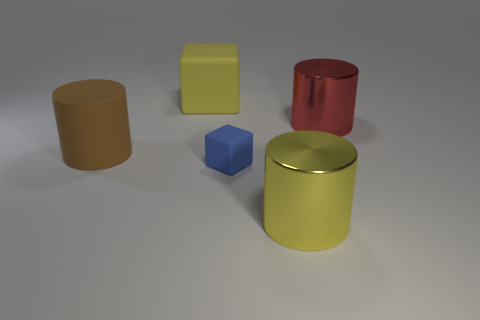Can you guess the texture of the objects? The objects appear to have smooth surfaces with no discernible texture, which is often indicative of materials such as plastic or metal. There are no visible grains, bumps, or irregularities that would suggest a textured material.  Considering their shapes, how do these objects look like they could be used? The shapes of the objects suggest they could be generic containers or purely decorative. The cylinders could function as storage canisters or vases, while the cube may serve as a paperweight or another form of geometric decoration. Their usage would be particular to the individual who owns them, as their simple shapes allow for multiple functions. 